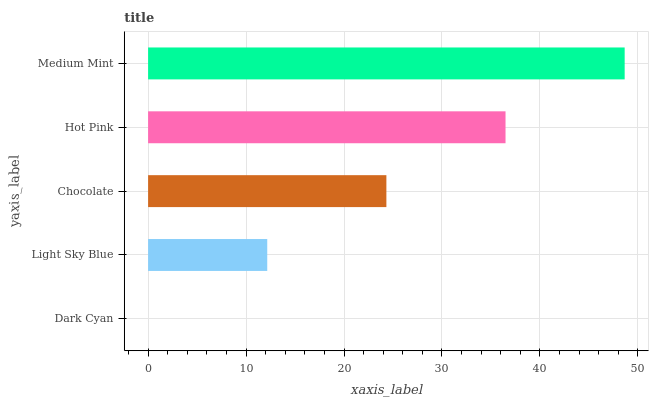Is Dark Cyan the minimum?
Answer yes or no. Yes. Is Medium Mint the maximum?
Answer yes or no. Yes. Is Light Sky Blue the minimum?
Answer yes or no. No. Is Light Sky Blue the maximum?
Answer yes or no. No. Is Light Sky Blue greater than Dark Cyan?
Answer yes or no. Yes. Is Dark Cyan less than Light Sky Blue?
Answer yes or no. Yes. Is Dark Cyan greater than Light Sky Blue?
Answer yes or no. No. Is Light Sky Blue less than Dark Cyan?
Answer yes or no. No. Is Chocolate the high median?
Answer yes or no. Yes. Is Chocolate the low median?
Answer yes or no. Yes. Is Dark Cyan the high median?
Answer yes or no. No. Is Hot Pink the low median?
Answer yes or no. No. 